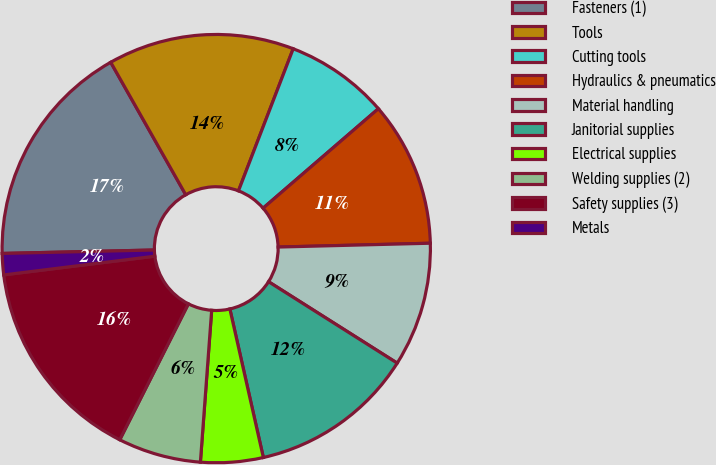Convert chart to OTSL. <chart><loc_0><loc_0><loc_500><loc_500><pie_chart><fcel>Fasteners (1)<fcel>Tools<fcel>Cutting tools<fcel>Hydraulics & pneumatics<fcel>Material handling<fcel>Janitorial supplies<fcel>Electrical supplies<fcel>Welding supplies (2)<fcel>Safety supplies (3)<fcel>Metals<nl><fcel>17.16%<fcel>14.05%<fcel>7.82%<fcel>10.93%<fcel>9.38%<fcel>12.49%<fcel>4.71%<fcel>6.26%<fcel>15.6%<fcel>1.6%<nl></chart> 